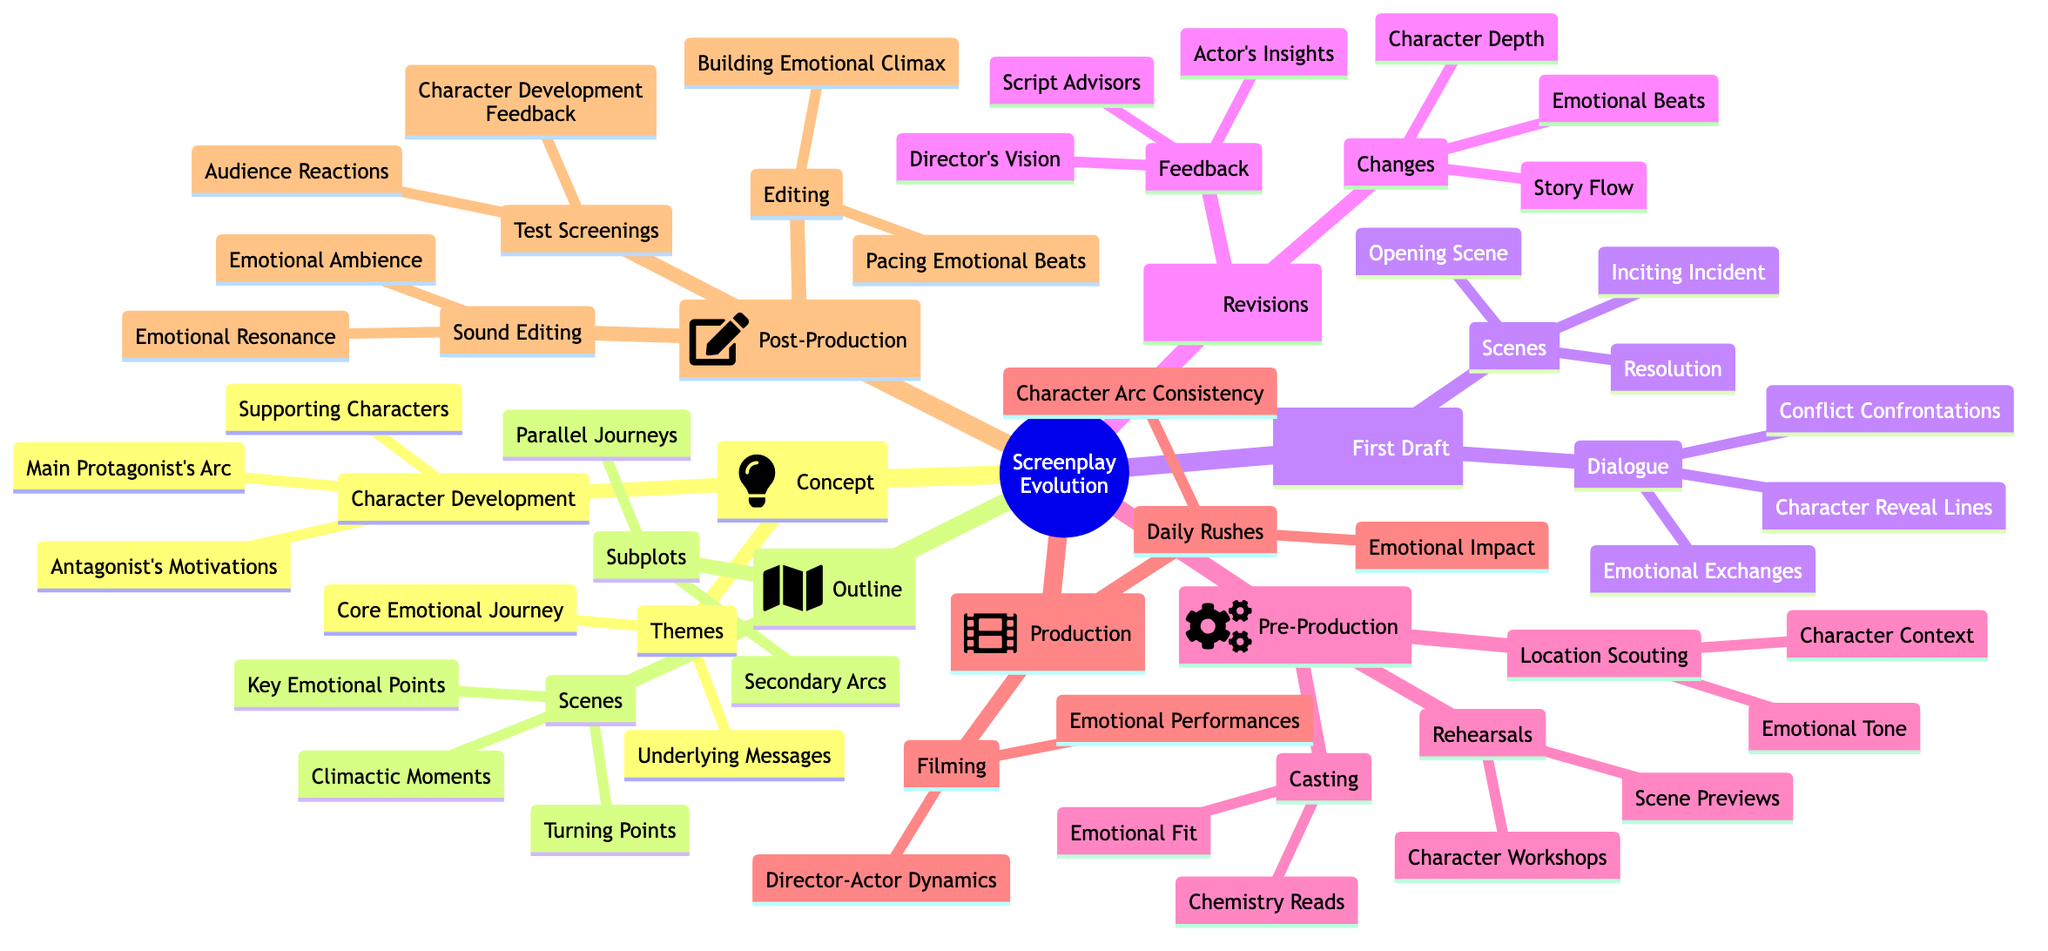What is the initial idea in the screenplay evolution? The initial idea, or theme, that sparks the creation of the screenplay is categorized under the "Concept" node, making it the fundamental starting point of the screenplay.
Answer: Initial idea or theme How many character development elements are listed under the Concept? By reviewing the "Character Development" section within the "Concept" node, there are three specific elements mentioned that focus on character arcs and backstories.
Answer: 3 What is a key responsibility during Pre-Production? Within the "Pre-Production" node, a crucial responsibility is to choose actors for their emotional fit, ensuring they align with the screenplay’s emotional tone and character needs.
Answer: Choosing Actors for Emotional Fit What is one of the changes made during the Revisions phase? The "Changes" section of the "Revisions" node lists different enhancements made based on feedback, including one specific aspect that refers to the depth added in character development, indicating a focus on emotional complexity.
Answer: Depth in Character Development Which phase of the screenplay evolution focuses on capturing emotional performances? In the "Production" phase, the responsibility of capturing emotional performances is explicitly mentioned under the "Filming" section, showcasing the importance of emotional expression during this stage of filmmaking.
Answer: Filming What are the two distinct aims of the Editing process in Post-Production? The "Editing" section in "Post-Production" highlights two main objectives: pacing the emotional beats to control the film’s rhythm and building the emotional climax to heighten tension at critical moments. This requires careful management of pacing and narrative structure.
Answer: Pacing Emotional Beats, Building Emotional Climax What aspect is emphasized in the Sound Editing of the Post-Production phase? The "Sound Editing" segment of "Post-Production" emphasizes enhancing the emotional ambience, vital for setting the mood and tone of scenes, as well as ensuring the scoring resonates emotionally during key moments of the film.
Answer: Enhancing Emotional Ambience What is the purpose of Test Screenings in Post-Production? The purpose of Test Screenings, as noted in the "Test Screenings" section of the "Post-Production" phase, is to gauge audience emotional reactions and gather feedback focused on character development, making it a step toward refining the final product.
Answer: Audience Emotional Reactions Which primary element in the Outline details key emotional high points? The "Scenes" section of the "Outline" node specifically mentions "Key Emotional High Points" as a significant element that highlights critical moments in the screenplay, affecting character development and audience engagement.
Answer: Key Emotional High Points 